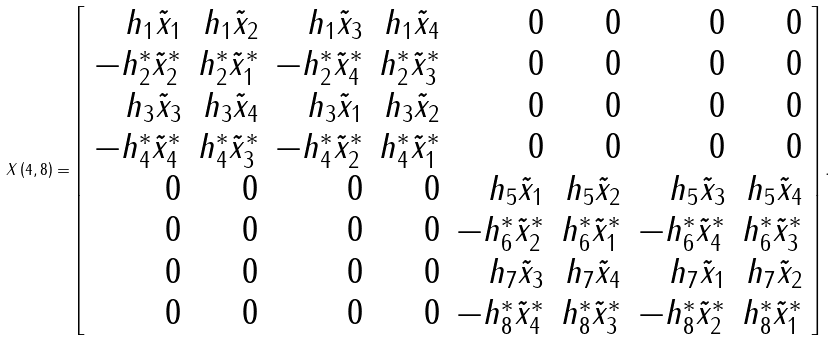<formula> <loc_0><loc_0><loc_500><loc_500>X \left ( 4 , 8 \right ) = \left [ \begin{array} { r r r r r r r r } h _ { 1 } \tilde { x } _ { 1 } & h _ { 1 } \tilde { x } _ { 2 } & h _ { 1 } \tilde { x } _ { 3 } & h _ { 1 } \tilde { x } _ { 4 } & 0 & 0 & 0 & 0 \\ - h _ { 2 } ^ { * } \tilde { x } _ { 2 } ^ { * } & h _ { 2 } ^ { * } \tilde { x } _ { 1 } ^ { * } & - h _ { 2 } ^ { * } \tilde { x } _ { 4 } ^ { * } & h _ { 2 } ^ { * } \tilde { x } _ { 3 } ^ { * } & 0 & 0 & 0 & 0 \\ h _ { 3 } \tilde { x } _ { 3 } & h _ { 3 } \tilde { x } _ { 4 } & h _ { 3 } \tilde { x } _ { 1 } & h _ { 3 } \tilde { x } _ { 2 } & 0 & 0 & 0 & 0 \\ - h _ { 4 } ^ { * } \tilde { x } _ { 4 } ^ { * } & h _ { 4 } ^ { * } \tilde { x } _ { 3 } ^ { * } & - h _ { 4 } ^ { * } \tilde { x } _ { 2 } ^ { * } & h _ { 4 } ^ { * } \tilde { x } _ { 1 } ^ { * } & 0 & 0 & 0 & 0 \\ 0 & 0 & 0 & 0 & h _ { 5 } \tilde { x } _ { 1 } & h _ { 5 } \tilde { x } _ { 2 } & h _ { 5 } \tilde { x } _ { 3 } & h _ { 5 } \tilde { x } _ { 4 } \\ 0 & 0 & 0 & 0 & - h _ { 6 } ^ { * } \tilde { x } _ { 2 } ^ { * } & h _ { 6 } ^ { * } \tilde { x } _ { 1 } ^ { * } & - h _ { 6 } ^ { * } \tilde { x } _ { 4 } ^ { * } & h _ { 6 } ^ { * } \tilde { x } _ { 3 } ^ { * } \\ 0 & 0 & 0 & 0 & h _ { 7 } \tilde { x } _ { 3 } & h _ { 7 } \tilde { x } _ { 4 } & h _ { 7 } \tilde { x } _ { 1 } & h _ { 7 } \tilde { x } _ { 2 } \\ 0 & 0 & 0 & 0 & - h _ { 8 } ^ { * } \tilde { x } _ { 4 } ^ { * } & h _ { 8 } ^ { * } \tilde { x } _ { 3 } ^ { * } & - h _ { 8 } ^ { * } \tilde { x } _ { 2 } ^ { * } & h _ { 8 } ^ { * } \tilde { x } _ { 1 } ^ { * } \end{array} \right ] . \\</formula> 